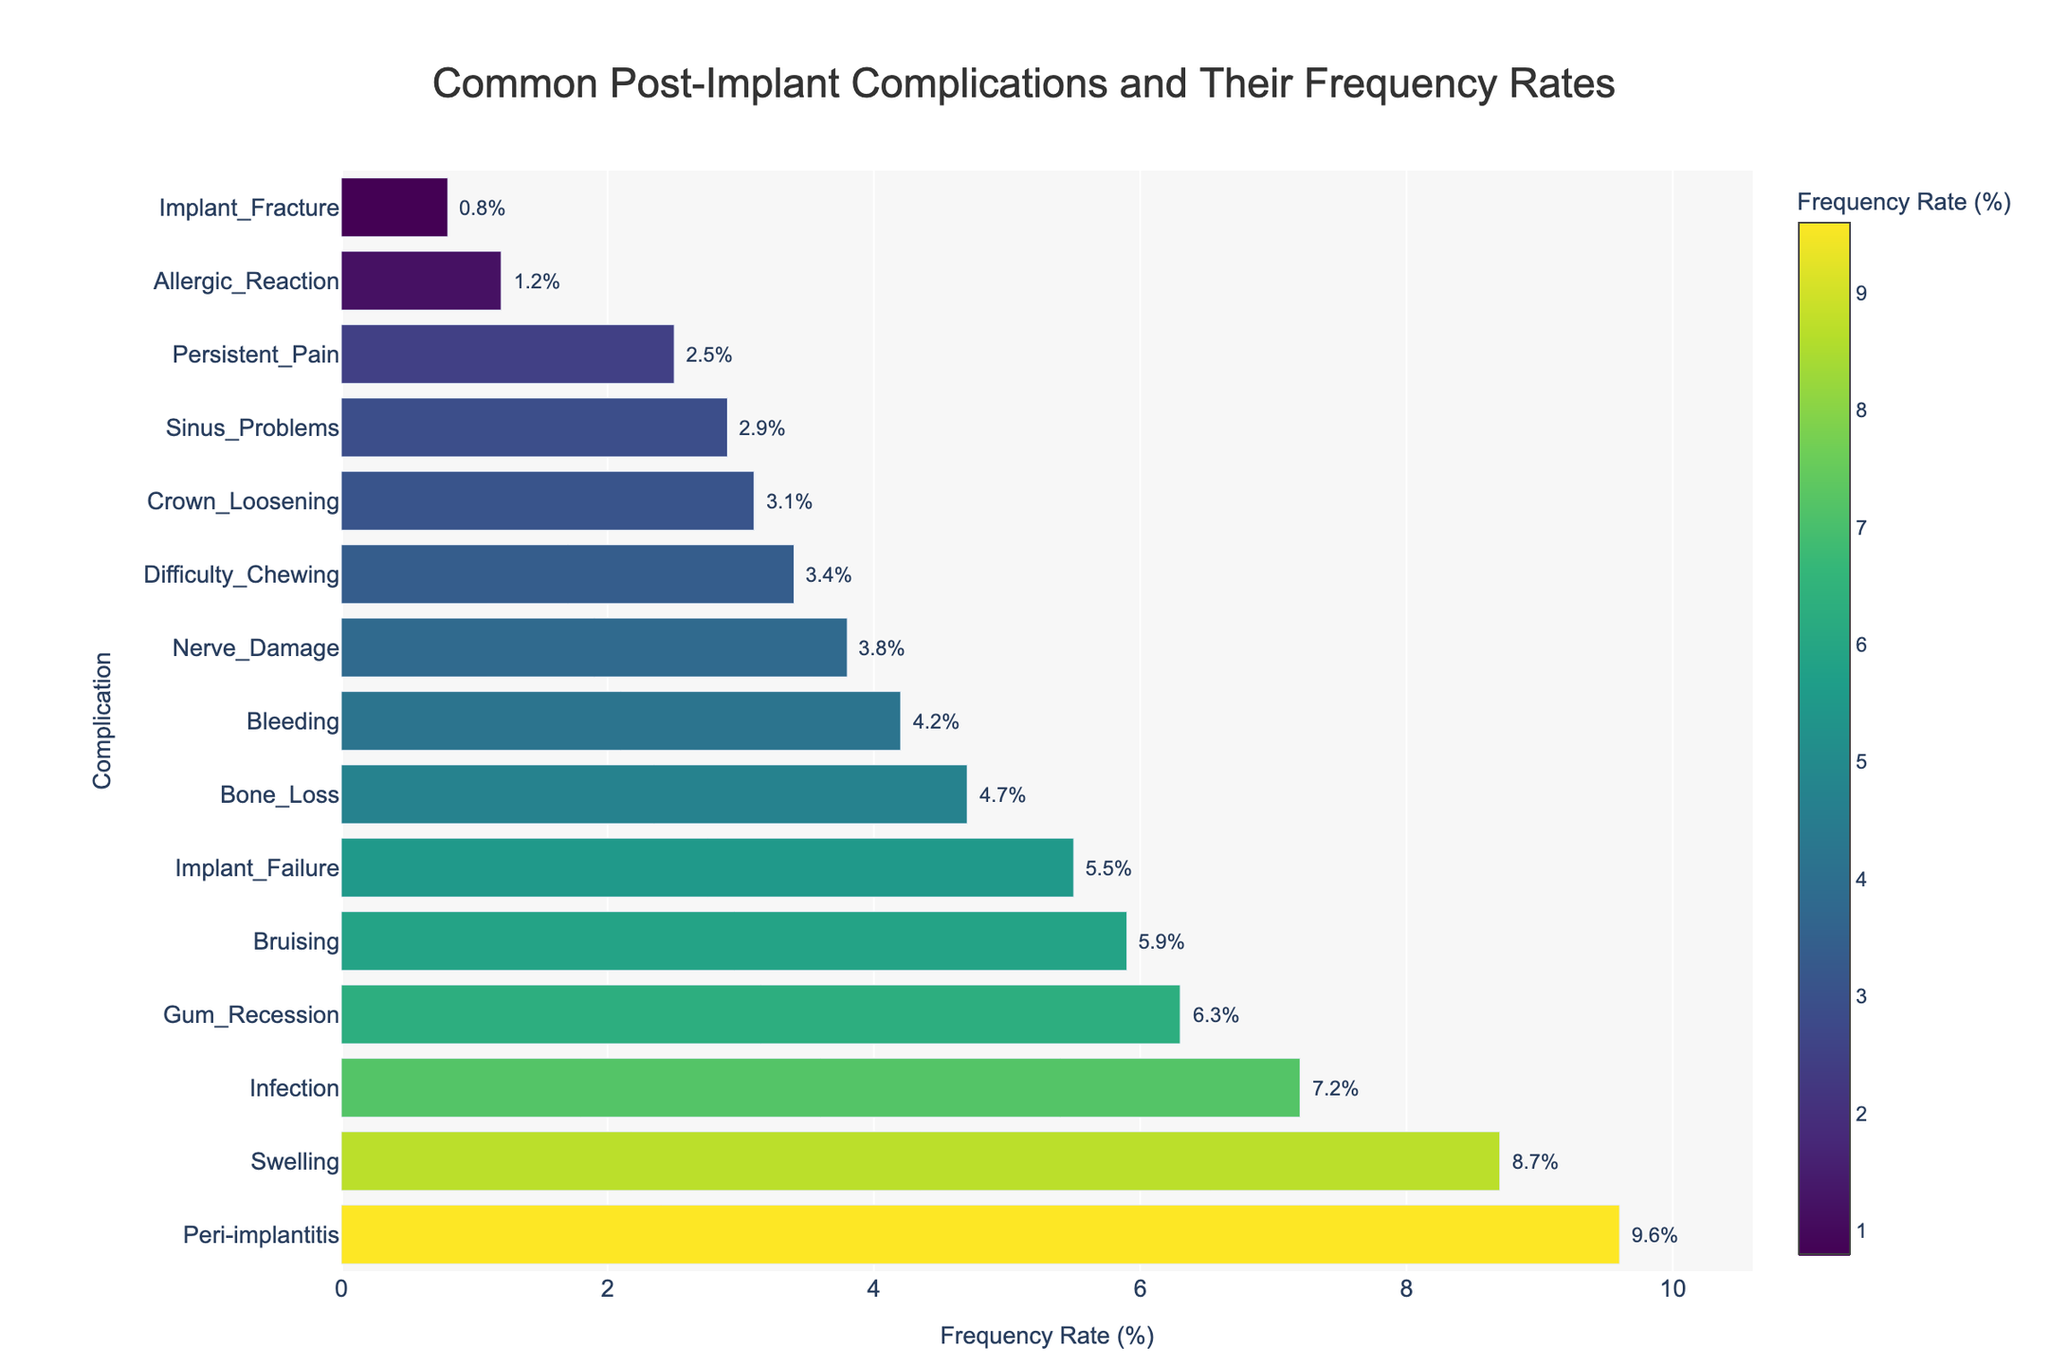Which complication has the highest frequency rate? By examining the length of each bar, the complication with the longest bar at the top of the chart represents the highest frequency rate, which is "Peri-implantitis" at 9.6%.
Answer: Peri-implantitis Which complication has the lowest frequency rate? By examining the shortest bar in the chart, "Implant_Fracture" has the lowest frequency rate at 0.8%.
Answer: Implant_Fracture How many complications have a frequency rate greater than 5%? Count the number of bars that extend beyond the 5% mark. The complications are Peri-implantitis, Swelling, Infection, Bruising, Gum_Recession, and Implant_Failure, which are 6 complications in total.
Answer: 6 What is the difference in frequency rate between Swelling and Persistent Pain? Locate the frequency rates for Swelling (8.7%) and Persistent Pain (2.5%). Subtract the smaller from the larger: 8.7% - 2.5% = 6.2%.
Answer: 6.2% What is the average frequency rate of Nerve Damage, Sinus Problems, and Difficulty Chewing? Add the frequency rates of Nerve Damage (3.8%), Sinus Problems (2.9%), and Difficulty Chewing (3.4%), then divide by 3: (3.8 + 2.9 + 3.4) / 3 = 3.37%.
Answer: 3.37% Compare the frequency rates of Infection and Bleeding. Which is higher and by how much? The frequency rate for Infection is 7.2% and for Bleeding is 4.2%. Infection is higher: 7.2% - 4.2% = 3.0%.
Answer: Infection by 3.0% What is the combined frequency rate of Bone Loss and Crown Loosening? Add the frequency rates of Bone Loss (4.7%) and Crown Loosening (3.1%): 4.7% + 3.1% = 7.8%.
Answer: 7.8% Which complications fall within the frequency rate range of 2% to 5%? Identify the bars between 2% and 5%: Nerve Damage (3.8%), Sinus Problems (2.9%), Bone Loss (4.7%), Crown Loosening (3.1%), Persistent Pain (2.5%), and Bleeding (4.2%).
Answer: Nerve Damage, Sinus Problems, Bone Loss, Crown Loosening, Persistent Pain, Bleeding What is the median frequency rate of the listed complications? Sort the frequency rates: [0.8, 1.2, 2.5, 2.9, 3.1, 3.4, 3.8, 4.2, 4.7, 5.5, 5.9, 6.3, 7.2, 8.7, 9.6], the middle value (8th in the list) is the median, which is 4.2%.
Answer: 4.2% 